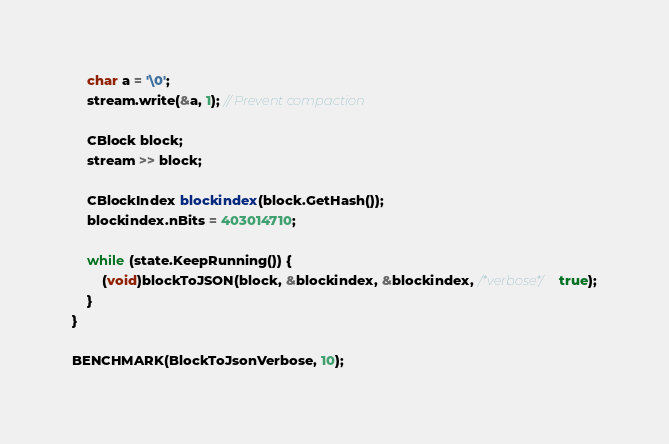Convert code to text. <code><loc_0><loc_0><loc_500><loc_500><_C++_>    char a = '\0';
    stream.write(&a, 1); // Prevent compaction

    CBlock block;
    stream >> block;

    CBlockIndex blockindex(block.GetHash());
    blockindex.nBits = 403014710;

    while (state.KeepRunning()) {
        (void)blockToJSON(block, &blockindex, &blockindex, /*verbose*/ true);
    }
}

BENCHMARK(BlockToJsonVerbose, 10);
</code> 